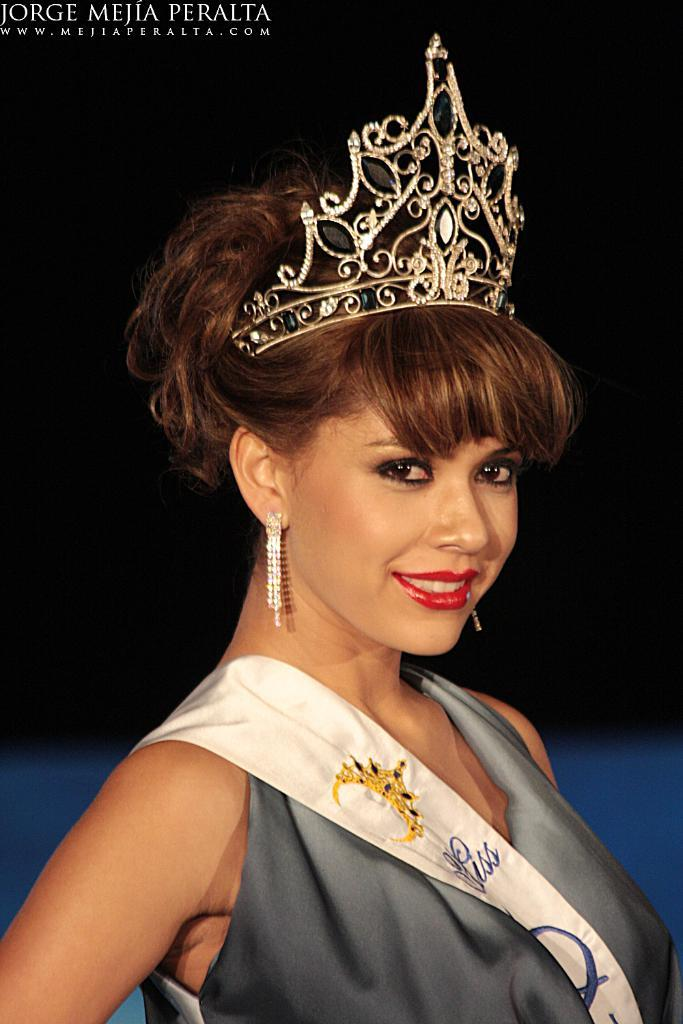Who is the main subject in the image? There is a woman in the image. What is the woman wearing? The woman is wearing a gray dress and a crown. What expression does the woman have? The woman is smiling. What can be seen in the top left corner of the image? There is a watermark in the top left corner of the image. How would you describe the background of the image? The background of the image is dark in color. What type of force is being applied to the hammer in the image? There is no hammer present in the image. What time of day is it in the image? The provided facts do not mention the time of day, so it cannot be determined from the image. 